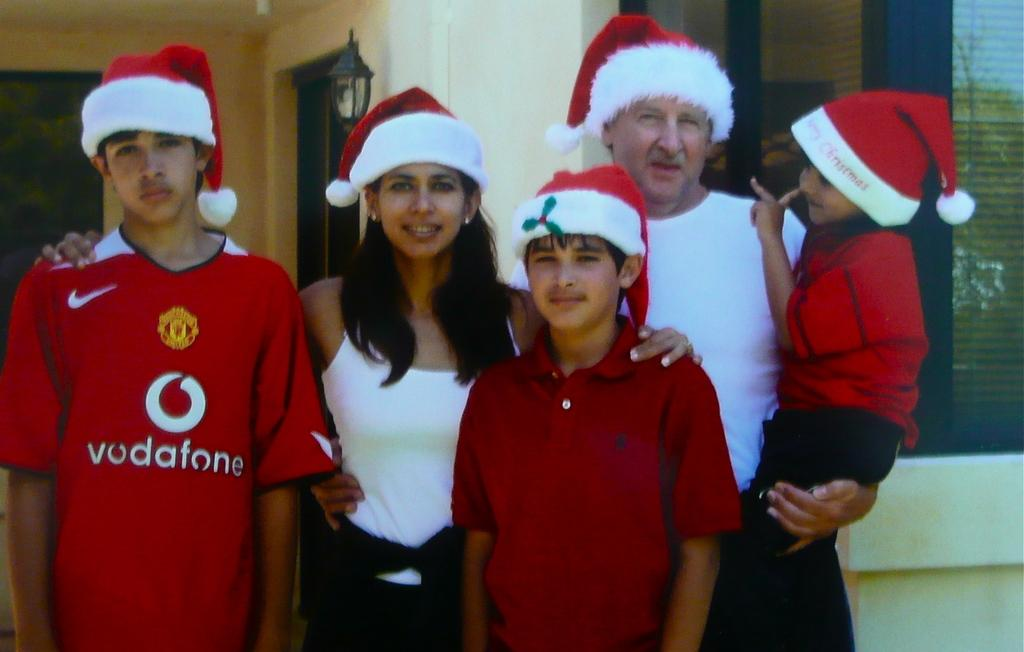<image>
Describe the image concisely. Five people pose for a photograph, one of whom is wearing a vodafone t-shirt. 